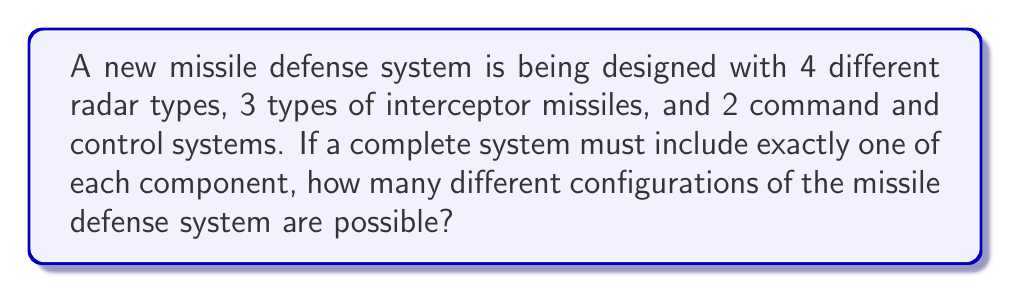Teach me how to tackle this problem. To solve this problem, we need to use the multiplication principle of counting. This principle states that if we have a series of independent choices, the total number of possible outcomes is the product of the number of possibilities for each choice.

In this case, we have three independent choices to make:

1. Choose a radar type: There are 4 options
2. Choose an interceptor missile type: There are 3 options
3. Choose a command and control system: There are 2 options

For each choice, we must select exactly one option. The choices are independent of each other, meaning the selection of one component does not affect the options available for the other components.

Therefore, we can calculate the total number of possible configurations as follows:

$$ \text{Total configurations} = \text{Radar options} \times \text{Interceptor options} \times \text{Command and control options} $$

$$ \text{Total configurations} = 4 \times 3 \times 2 $$

$$ \text{Total configurations} = 24 $$

This calculation gives us the total number of ways to select one option from each category, resulting in all possible unique configurations of the missile defense system.
Answer: 24 possible configurations 